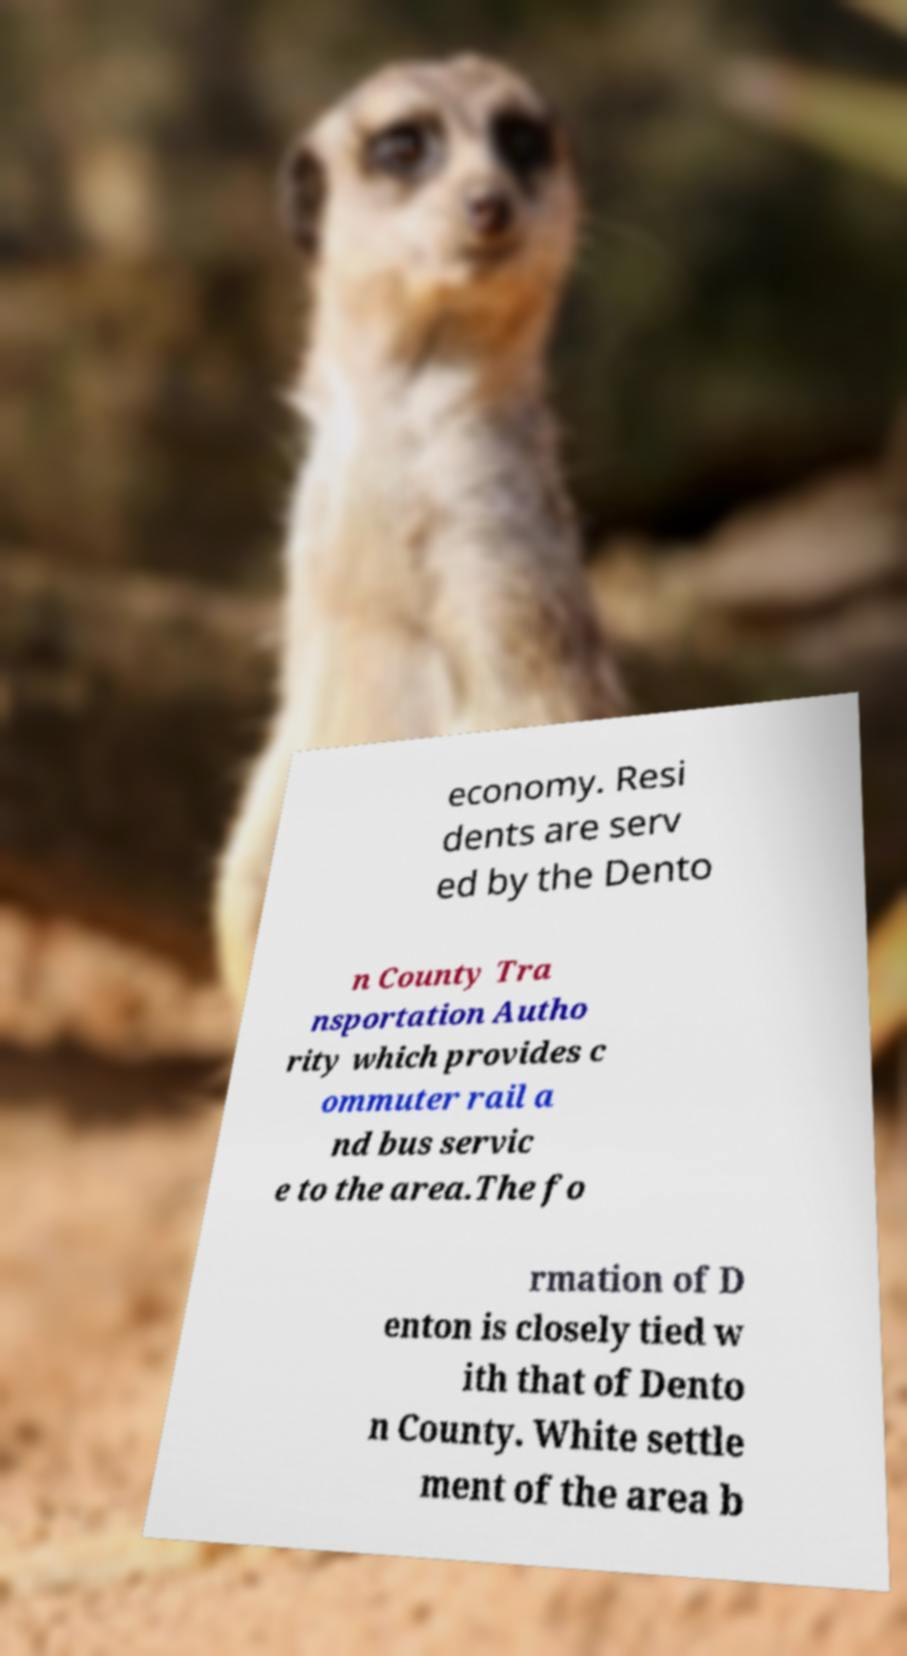There's text embedded in this image that I need extracted. Can you transcribe it verbatim? economy. Resi dents are serv ed by the Dento n County Tra nsportation Autho rity which provides c ommuter rail a nd bus servic e to the area.The fo rmation of D enton is closely tied w ith that of Dento n County. White settle ment of the area b 